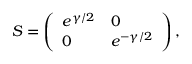Convert formula to latex. <formula><loc_0><loc_0><loc_500><loc_500>S = \left ( \begin{array} { l l } { { e ^ { \gamma / 2 } } } & { 0 } \\ { 0 } & { { e ^ { - \gamma / 2 } } } \end{array} \right ) ,</formula> 